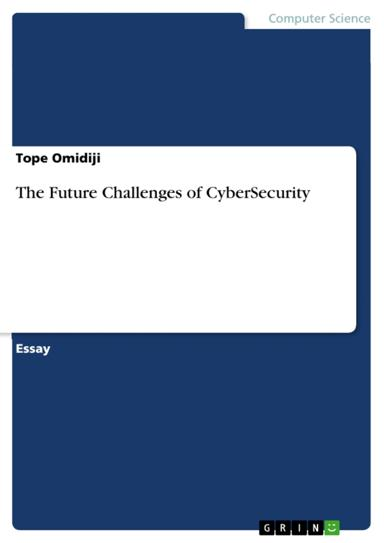How relevant do you think this essay is to current events in technology? Given the rapid advancements in technology and the corresponding rise in cyber threats, it's highly probable that an essay discussing "The Future Challenges of CyberSecurity" is significantly relevant. It likely addresses contemporary issues such as data breaches, privacy concerns, and the need for robust security protocols in both private and public sectors. 